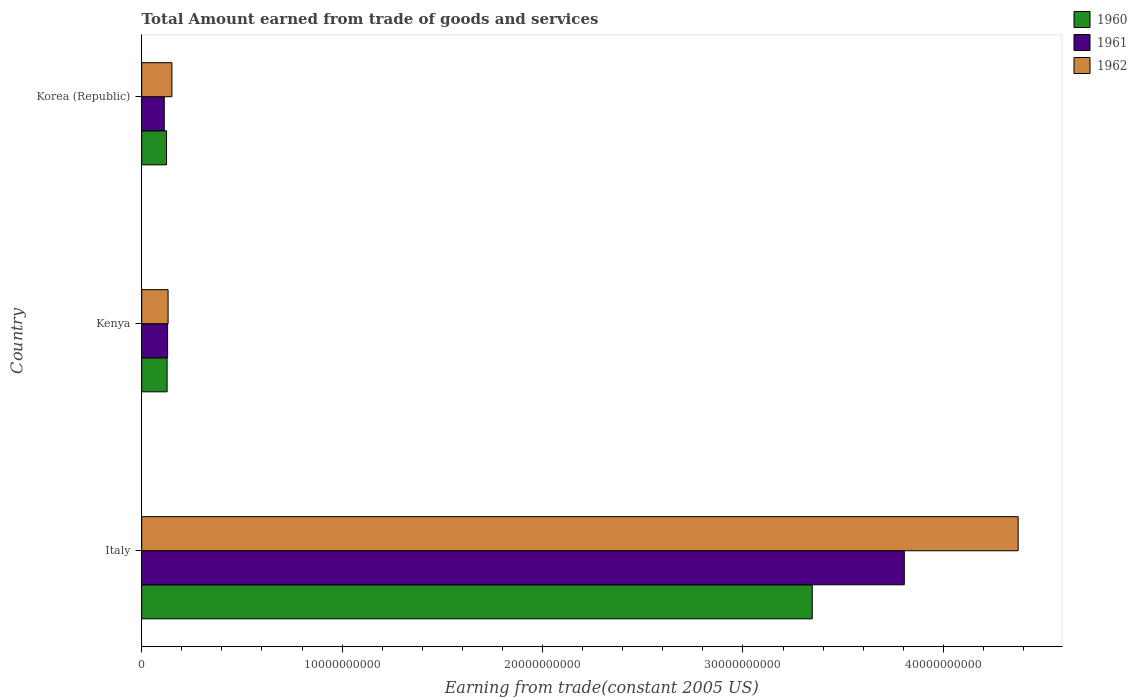How many different coloured bars are there?
Provide a succinct answer. 3. How many groups of bars are there?
Provide a short and direct response. 3. Are the number of bars per tick equal to the number of legend labels?
Give a very brief answer. Yes. In how many cases, is the number of bars for a given country not equal to the number of legend labels?
Ensure brevity in your answer.  0. What is the total amount earned by trading goods and services in 1961 in Korea (Republic)?
Offer a terse response. 1.12e+09. Across all countries, what is the maximum total amount earned by trading goods and services in 1960?
Give a very brief answer. 3.35e+1. Across all countries, what is the minimum total amount earned by trading goods and services in 1960?
Make the answer very short. 1.24e+09. In which country was the total amount earned by trading goods and services in 1961 minimum?
Your response must be concise. Korea (Republic). What is the total total amount earned by trading goods and services in 1962 in the graph?
Your answer should be compact. 4.66e+1. What is the difference between the total amount earned by trading goods and services in 1960 in Italy and that in Kenya?
Make the answer very short. 3.22e+1. What is the difference between the total amount earned by trading goods and services in 1960 in Italy and the total amount earned by trading goods and services in 1961 in Korea (Republic)?
Offer a very short reply. 3.23e+1. What is the average total amount earned by trading goods and services in 1962 per country?
Offer a very short reply. 1.55e+1. What is the difference between the total amount earned by trading goods and services in 1962 and total amount earned by trading goods and services in 1961 in Italy?
Provide a short and direct response. 5.68e+09. In how many countries, is the total amount earned by trading goods and services in 1960 greater than 4000000000 US$?
Your response must be concise. 1. What is the ratio of the total amount earned by trading goods and services in 1961 in Italy to that in Kenya?
Your answer should be compact. 29.47. Is the total amount earned by trading goods and services in 1961 in Kenya less than that in Korea (Republic)?
Ensure brevity in your answer.  No. Is the difference between the total amount earned by trading goods and services in 1962 in Italy and Korea (Republic) greater than the difference between the total amount earned by trading goods and services in 1961 in Italy and Korea (Republic)?
Your answer should be very brief. Yes. What is the difference between the highest and the second highest total amount earned by trading goods and services in 1960?
Provide a short and direct response. 3.22e+1. What is the difference between the highest and the lowest total amount earned by trading goods and services in 1962?
Your answer should be very brief. 4.24e+1. Is it the case that in every country, the sum of the total amount earned by trading goods and services in 1961 and total amount earned by trading goods and services in 1962 is greater than the total amount earned by trading goods and services in 1960?
Make the answer very short. Yes. How many countries are there in the graph?
Ensure brevity in your answer.  3. Does the graph contain grids?
Offer a very short reply. No. Where does the legend appear in the graph?
Your response must be concise. Top right. What is the title of the graph?
Your answer should be very brief. Total Amount earned from trade of goods and services. What is the label or title of the X-axis?
Provide a short and direct response. Earning from trade(constant 2005 US). What is the Earning from trade(constant 2005 US) in 1960 in Italy?
Give a very brief answer. 3.35e+1. What is the Earning from trade(constant 2005 US) of 1961 in Italy?
Make the answer very short. 3.81e+1. What is the Earning from trade(constant 2005 US) of 1962 in Italy?
Provide a succinct answer. 4.37e+1. What is the Earning from trade(constant 2005 US) of 1960 in Kenya?
Keep it short and to the point. 1.27e+09. What is the Earning from trade(constant 2005 US) in 1961 in Kenya?
Offer a very short reply. 1.29e+09. What is the Earning from trade(constant 2005 US) in 1962 in Kenya?
Keep it short and to the point. 1.32e+09. What is the Earning from trade(constant 2005 US) in 1960 in Korea (Republic)?
Your answer should be compact. 1.24e+09. What is the Earning from trade(constant 2005 US) of 1961 in Korea (Republic)?
Make the answer very short. 1.12e+09. What is the Earning from trade(constant 2005 US) of 1962 in Korea (Republic)?
Provide a succinct answer. 1.51e+09. Across all countries, what is the maximum Earning from trade(constant 2005 US) of 1960?
Ensure brevity in your answer.  3.35e+1. Across all countries, what is the maximum Earning from trade(constant 2005 US) of 1961?
Offer a terse response. 3.81e+1. Across all countries, what is the maximum Earning from trade(constant 2005 US) in 1962?
Make the answer very short. 4.37e+1. Across all countries, what is the minimum Earning from trade(constant 2005 US) of 1960?
Your answer should be compact. 1.24e+09. Across all countries, what is the minimum Earning from trade(constant 2005 US) in 1961?
Keep it short and to the point. 1.12e+09. Across all countries, what is the minimum Earning from trade(constant 2005 US) of 1962?
Keep it short and to the point. 1.32e+09. What is the total Earning from trade(constant 2005 US) of 1960 in the graph?
Your response must be concise. 3.60e+1. What is the total Earning from trade(constant 2005 US) of 1961 in the graph?
Offer a very short reply. 4.05e+1. What is the total Earning from trade(constant 2005 US) in 1962 in the graph?
Offer a terse response. 4.66e+1. What is the difference between the Earning from trade(constant 2005 US) of 1960 in Italy and that in Kenya?
Your answer should be compact. 3.22e+1. What is the difference between the Earning from trade(constant 2005 US) of 1961 in Italy and that in Kenya?
Your answer should be very brief. 3.68e+1. What is the difference between the Earning from trade(constant 2005 US) of 1962 in Italy and that in Kenya?
Offer a very short reply. 4.24e+1. What is the difference between the Earning from trade(constant 2005 US) of 1960 in Italy and that in Korea (Republic)?
Ensure brevity in your answer.  3.22e+1. What is the difference between the Earning from trade(constant 2005 US) in 1961 in Italy and that in Korea (Republic)?
Offer a very short reply. 3.69e+1. What is the difference between the Earning from trade(constant 2005 US) of 1962 in Italy and that in Korea (Republic)?
Offer a terse response. 4.22e+1. What is the difference between the Earning from trade(constant 2005 US) in 1960 in Kenya and that in Korea (Republic)?
Your answer should be compact. 2.90e+07. What is the difference between the Earning from trade(constant 2005 US) in 1961 in Kenya and that in Korea (Republic)?
Offer a very short reply. 1.67e+08. What is the difference between the Earning from trade(constant 2005 US) in 1962 in Kenya and that in Korea (Republic)?
Provide a succinct answer. -1.90e+08. What is the difference between the Earning from trade(constant 2005 US) in 1960 in Italy and the Earning from trade(constant 2005 US) in 1961 in Kenya?
Your answer should be compact. 3.22e+1. What is the difference between the Earning from trade(constant 2005 US) of 1960 in Italy and the Earning from trade(constant 2005 US) of 1962 in Kenya?
Ensure brevity in your answer.  3.21e+1. What is the difference between the Earning from trade(constant 2005 US) in 1961 in Italy and the Earning from trade(constant 2005 US) in 1962 in Kenya?
Offer a terse response. 3.67e+1. What is the difference between the Earning from trade(constant 2005 US) of 1960 in Italy and the Earning from trade(constant 2005 US) of 1961 in Korea (Republic)?
Your answer should be very brief. 3.23e+1. What is the difference between the Earning from trade(constant 2005 US) of 1960 in Italy and the Earning from trade(constant 2005 US) of 1962 in Korea (Republic)?
Ensure brevity in your answer.  3.19e+1. What is the difference between the Earning from trade(constant 2005 US) in 1961 in Italy and the Earning from trade(constant 2005 US) in 1962 in Korea (Republic)?
Keep it short and to the point. 3.65e+1. What is the difference between the Earning from trade(constant 2005 US) in 1960 in Kenya and the Earning from trade(constant 2005 US) in 1961 in Korea (Republic)?
Your response must be concise. 1.42e+08. What is the difference between the Earning from trade(constant 2005 US) in 1960 in Kenya and the Earning from trade(constant 2005 US) in 1962 in Korea (Republic)?
Offer a terse response. -2.40e+08. What is the difference between the Earning from trade(constant 2005 US) of 1961 in Kenya and the Earning from trade(constant 2005 US) of 1962 in Korea (Republic)?
Offer a very short reply. -2.15e+08. What is the average Earning from trade(constant 2005 US) of 1960 per country?
Provide a succinct answer. 1.20e+1. What is the average Earning from trade(constant 2005 US) in 1961 per country?
Offer a terse response. 1.35e+1. What is the average Earning from trade(constant 2005 US) of 1962 per country?
Your answer should be compact. 1.55e+1. What is the difference between the Earning from trade(constant 2005 US) of 1960 and Earning from trade(constant 2005 US) of 1961 in Italy?
Your answer should be compact. -4.59e+09. What is the difference between the Earning from trade(constant 2005 US) of 1960 and Earning from trade(constant 2005 US) of 1962 in Italy?
Offer a very short reply. -1.03e+1. What is the difference between the Earning from trade(constant 2005 US) of 1961 and Earning from trade(constant 2005 US) of 1962 in Italy?
Provide a succinct answer. -5.68e+09. What is the difference between the Earning from trade(constant 2005 US) in 1960 and Earning from trade(constant 2005 US) in 1961 in Kenya?
Give a very brief answer. -2.47e+07. What is the difference between the Earning from trade(constant 2005 US) in 1960 and Earning from trade(constant 2005 US) in 1962 in Kenya?
Your answer should be very brief. -4.93e+07. What is the difference between the Earning from trade(constant 2005 US) of 1961 and Earning from trade(constant 2005 US) of 1962 in Kenya?
Make the answer very short. -2.46e+07. What is the difference between the Earning from trade(constant 2005 US) of 1960 and Earning from trade(constant 2005 US) of 1961 in Korea (Republic)?
Ensure brevity in your answer.  1.13e+08. What is the difference between the Earning from trade(constant 2005 US) in 1960 and Earning from trade(constant 2005 US) in 1962 in Korea (Republic)?
Make the answer very short. -2.69e+08. What is the difference between the Earning from trade(constant 2005 US) in 1961 and Earning from trade(constant 2005 US) in 1962 in Korea (Republic)?
Give a very brief answer. -3.82e+08. What is the ratio of the Earning from trade(constant 2005 US) of 1960 in Italy to that in Kenya?
Provide a succinct answer. 26.41. What is the ratio of the Earning from trade(constant 2005 US) of 1961 in Italy to that in Kenya?
Make the answer very short. 29.47. What is the ratio of the Earning from trade(constant 2005 US) in 1962 in Italy to that in Kenya?
Ensure brevity in your answer.  33.23. What is the ratio of the Earning from trade(constant 2005 US) of 1960 in Italy to that in Korea (Republic)?
Provide a succinct answer. 27.03. What is the ratio of the Earning from trade(constant 2005 US) in 1961 in Italy to that in Korea (Republic)?
Keep it short and to the point. 33.84. What is the ratio of the Earning from trade(constant 2005 US) in 1962 in Italy to that in Korea (Republic)?
Keep it short and to the point. 29.03. What is the ratio of the Earning from trade(constant 2005 US) of 1960 in Kenya to that in Korea (Republic)?
Offer a very short reply. 1.02. What is the ratio of the Earning from trade(constant 2005 US) of 1961 in Kenya to that in Korea (Republic)?
Your response must be concise. 1.15. What is the ratio of the Earning from trade(constant 2005 US) in 1962 in Kenya to that in Korea (Republic)?
Keep it short and to the point. 0.87. What is the difference between the highest and the second highest Earning from trade(constant 2005 US) of 1960?
Your answer should be very brief. 3.22e+1. What is the difference between the highest and the second highest Earning from trade(constant 2005 US) of 1961?
Make the answer very short. 3.68e+1. What is the difference between the highest and the second highest Earning from trade(constant 2005 US) in 1962?
Offer a terse response. 4.22e+1. What is the difference between the highest and the lowest Earning from trade(constant 2005 US) of 1960?
Provide a succinct answer. 3.22e+1. What is the difference between the highest and the lowest Earning from trade(constant 2005 US) in 1961?
Ensure brevity in your answer.  3.69e+1. What is the difference between the highest and the lowest Earning from trade(constant 2005 US) in 1962?
Your answer should be compact. 4.24e+1. 